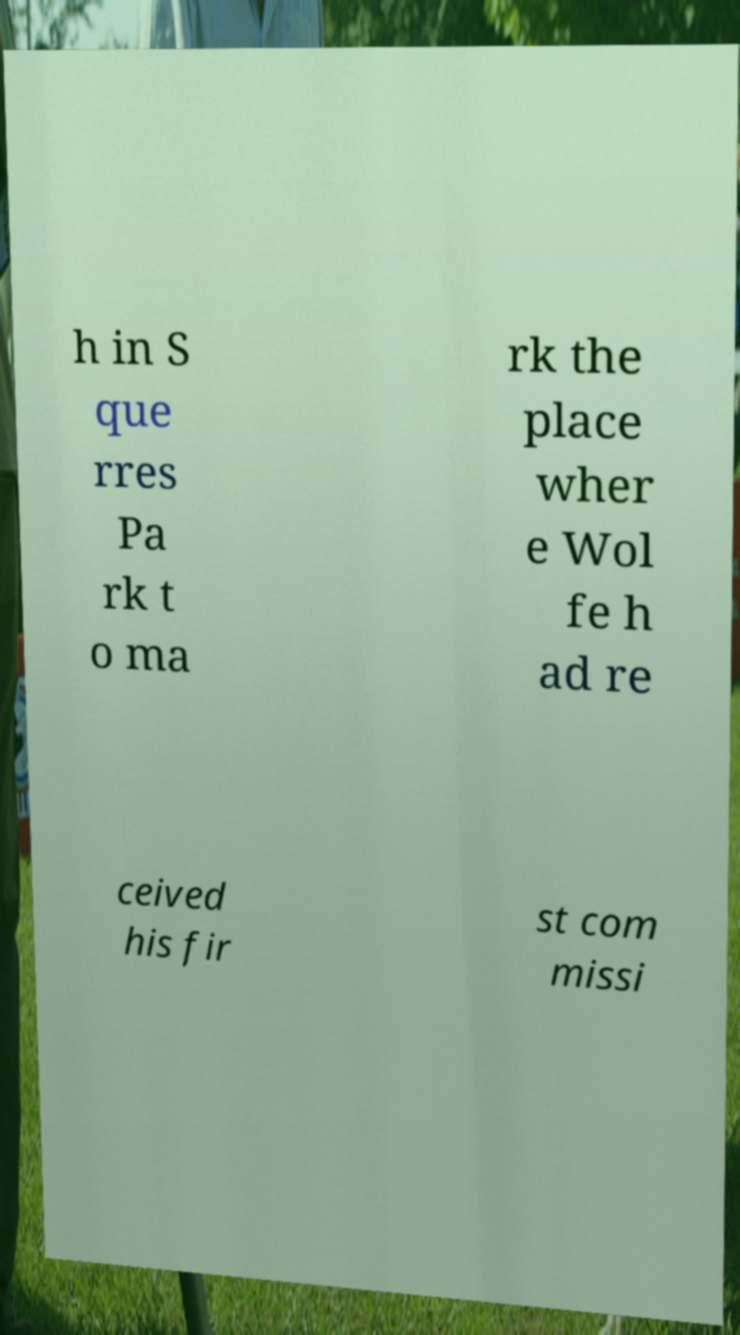What messages or text are displayed in this image? I need them in a readable, typed format. h in S que rres Pa rk t o ma rk the place wher e Wol fe h ad re ceived his fir st com missi 